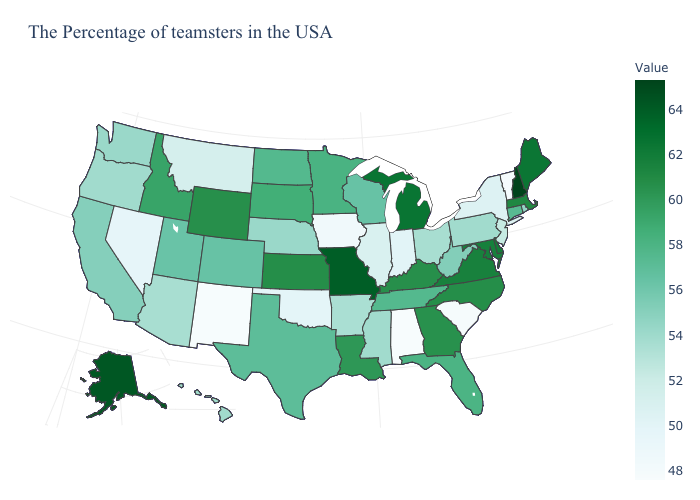Which states have the lowest value in the USA?
Be succinct. Alabama. Which states have the highest value in the USA?
Concise answer only. New Hampshire. Among the states that border Utah , does New Mexico have the lowest value?
Concise answer only. Yes. Does New Hampshire have the highest value in the USA?
Keep it brief. Yes. Does Alaska have the highest value in the West?
Keep it brief. Yes. Among the states that border Tennessee , which have the highest value?
Concise answer only. Missouri. Which states have the lowest value in the USA?
Write a very short answer. Alabama. 